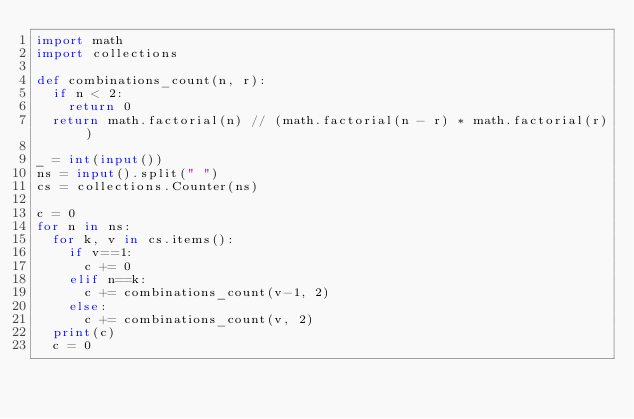<code> <loc_0><loc_0><loc_500><loc_500><_Python_>import math
import collections

def combinations_count(n, r):
	if n < 2:
		return 0
	return math.factorial(n) // (math.factorial(n - r) * math.factorial(r))

_ = int(input())
ns = input().split(" ")
cs = collections.Counter(ns)

c = 0
for n in ns:
	for k, v in cs.items():
		if v==1:
			c += 0
		elif n==k:
			c += combinations_count(v-1, 2)
		else:
			c += combinations_count(v, 2)
	print(c)
	c = 0</code> 